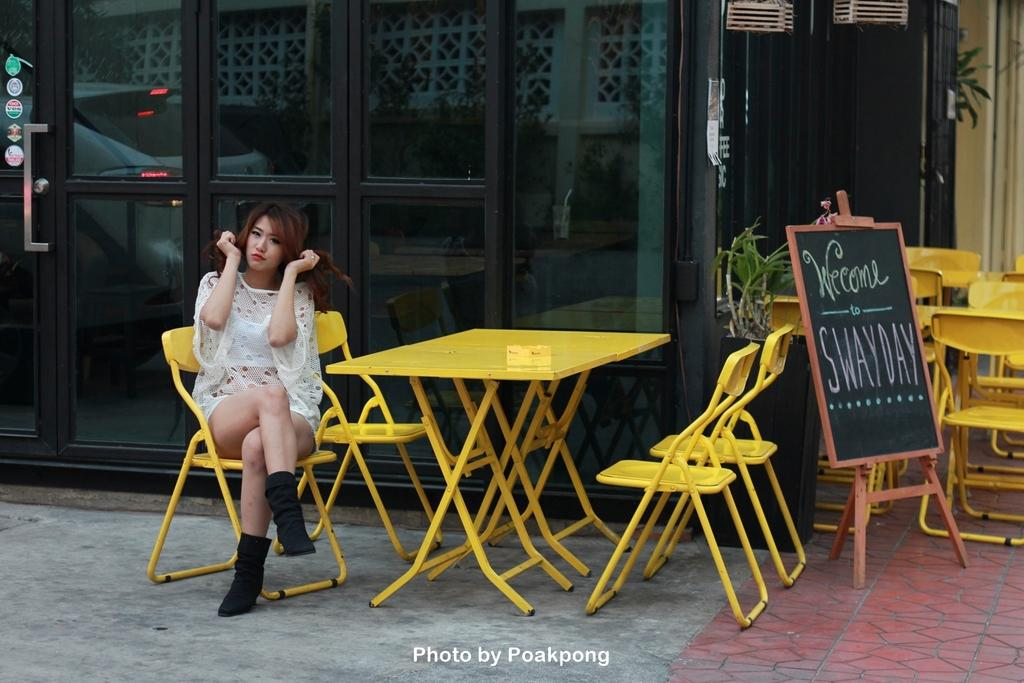What is the woman in the image doing? The woman is sitting in the image. What type of furniture is present in the image? There are chairs and a table in the image. What is on the table in the image? There is a board on the table in the image. What can be seen in the background of the image? There is a building in the background of the image. What type of stick can be seen in the woman's hand in the image? There is no stick present in the woman's hand or in the image. 